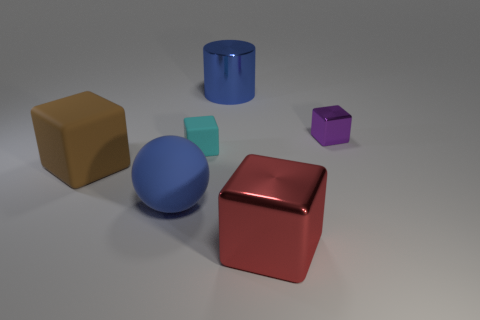Add 1 big brown blocks. How many objects exist? 7 Subtract all cylinders. How many objects are left? 5 Subtract all small blue things. Subtract all cyan things. How many objects are left? 5 Add 3 big rubber balls. How many big rubber balls are left? 4 Add 6 large blue things. How many large blue things exist? 8 Subtract 1 blue spheres. How many objects are left? 5 